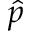<formula> <loc_0><loc_0><loc_500><loc_500>\hat { p }</formula> 